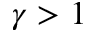<formula> <loc_0><loc_0><loc_500><loc_500>\gamma > 1</formula> 